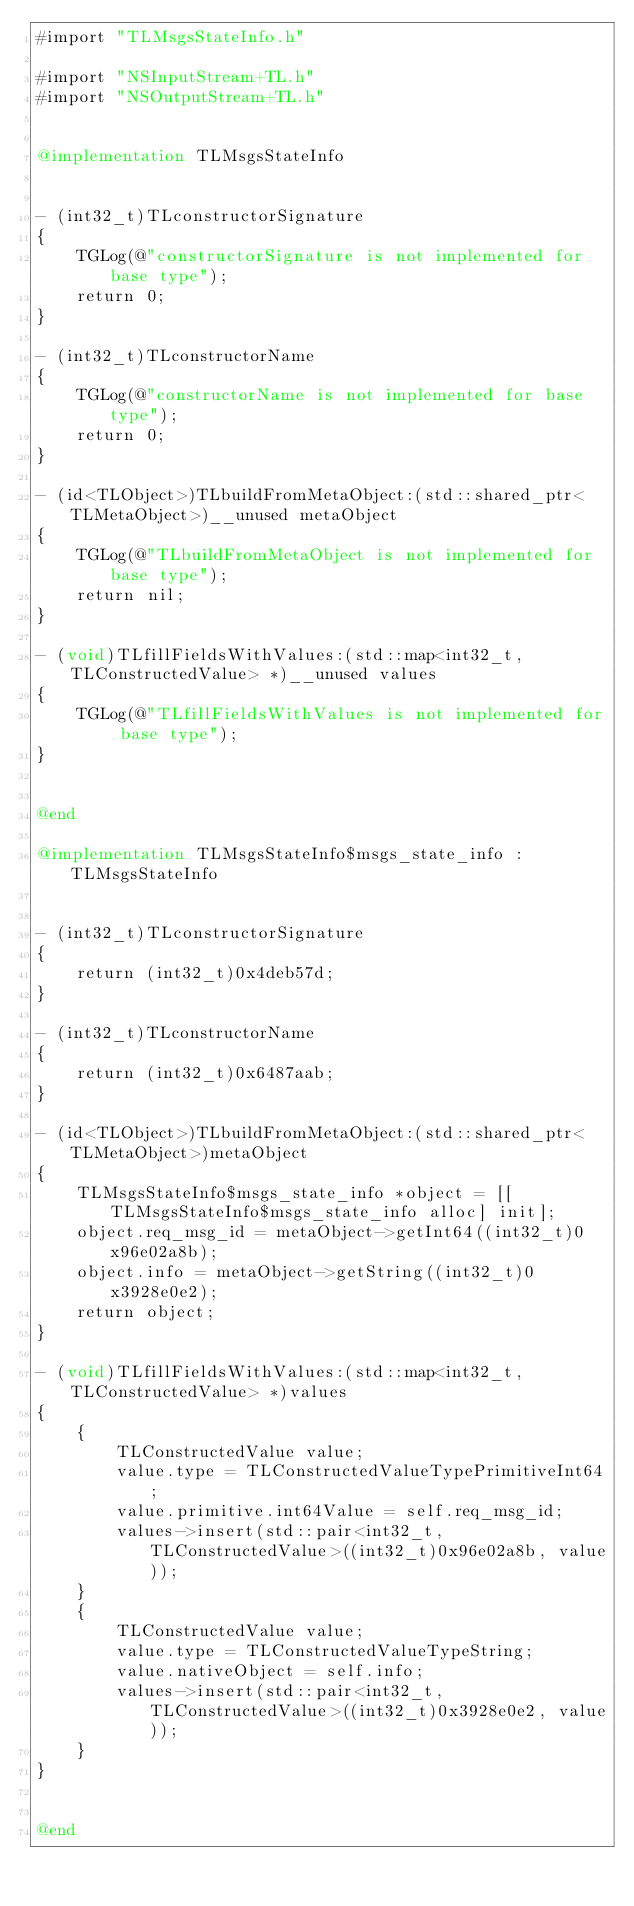Convert code to text. <code><loc_0><loc_0><loc_500><loc_500><_ObjectiveC_>#import "TLMsgsStateInfo.h"

#import "NSInputStream+TL.h"
#import "NSOutputStream+TL.h"


@implementation TLMsgsStateInfo


- (int32_t)TLconstructorSignature
{
    TGLog(@"constructorSignature is not implemented for base type");
    return 0;
}

- (int32_t)TLconstructorName
{
    TGLog(@"constructorName is not implemented for base type");
    return 0;
}

- (id<TLObject>)TLbuildFromMetaObject:(std::shared_ptr<TLMetaObject>)__unused metaObject
{
    TGLog(@"TLbuildFromMetaObject is not implemented for base type");
    return nil;
}

- (void)TLfillFieldsWithValues:(std::map<int32_t, TLConstructedValue> *)__unused values
{
    TGLog(@"TLfillFieldsWithValues is not implemented for base type");
}


@end

@implementation TLMsgsStateInfo$msgs_state_info : TLMsgsStateInfo


- (int32_t)TLconstructorSignature
{
    return (int32_t)0x4deb57d;
}

- (int32_t)TLconstructorName
{
    return (int32_t)0x6487aab;
}

- (id<TLObject>)TLbuildFromMetaObject:(std::shared_ptr<TLMetaObject>)metaObject
{
    TLMsgsStateInfo$msgs_state_info *object = [[TLMsgsStateInfo$msgs_state_info alloc] init];
    object.req_msg_id = metaObject->getInt64((int32_t)0x96e02a8b);
    object.info = metaObject->getString((int32_t)0x3928e0e2);
    return object;
}

- (void)TLfillFieldsWithValues:(std::map<int32_t, TLConstructedValue> *)values
{
    {
        TLConstructedValue value;
        value.type = TLConstructedValueTypePrimitiveInt64;
        value.primitive.int64Value = self.req_msg_id;
        values->insert(std::pair<int32_t, TLConstructedValue>((int32_t)0x96e02a8b, value));
    }
    {
        TLConstructedValue value;
        value.type = TLConstructedValueTypeString;
        value.nativeObject = self.info;
        values->insert(std::pair<int32_t, TLConstructedValue>((int32_t)0x3928e0e2, value));
    }
}


@end

</code> 